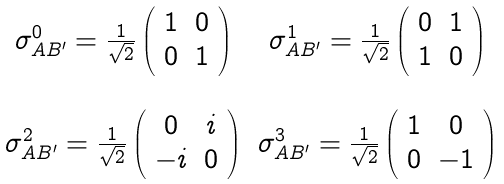<formula> <loc_0><loc_0><loc_500><loc_500>\begin{array} { c c } \sigma ^ { 0 } _ { A B ^ { \prime } } = \frac { 1 } { \sqrt { 2 } } \left ( \begin{array} { c c } 1 & 0 \\ 0 & 1 \\ \end{array} \right ) & \sigma ^ { 1 } _ { A B ^ { \prime } } = \frac { 1 } { \sqrt { 2 } } \left ( \begin{array} { c c } 0 & 1 \\ 1 & 0 \\ \end{array} \right ) \\ \\ \sigma ^ { 2 } _ { A B ^ { \prime } } = \frac { 1 } { \sqrt { 2 } } \left ( \begin{array} { c c } 0 & i \\ - i & 0 \\ \end{array} \right ) & \sigma ^ { 3 } _ { A B ^ { \prime } } = \frac { 1 } { \sqrt { 2 } } \left ( \begin{array} { c c } 1 & 0 \\ 0 & - 1 \\ \end{array} \right ) \end{array}</formula> 